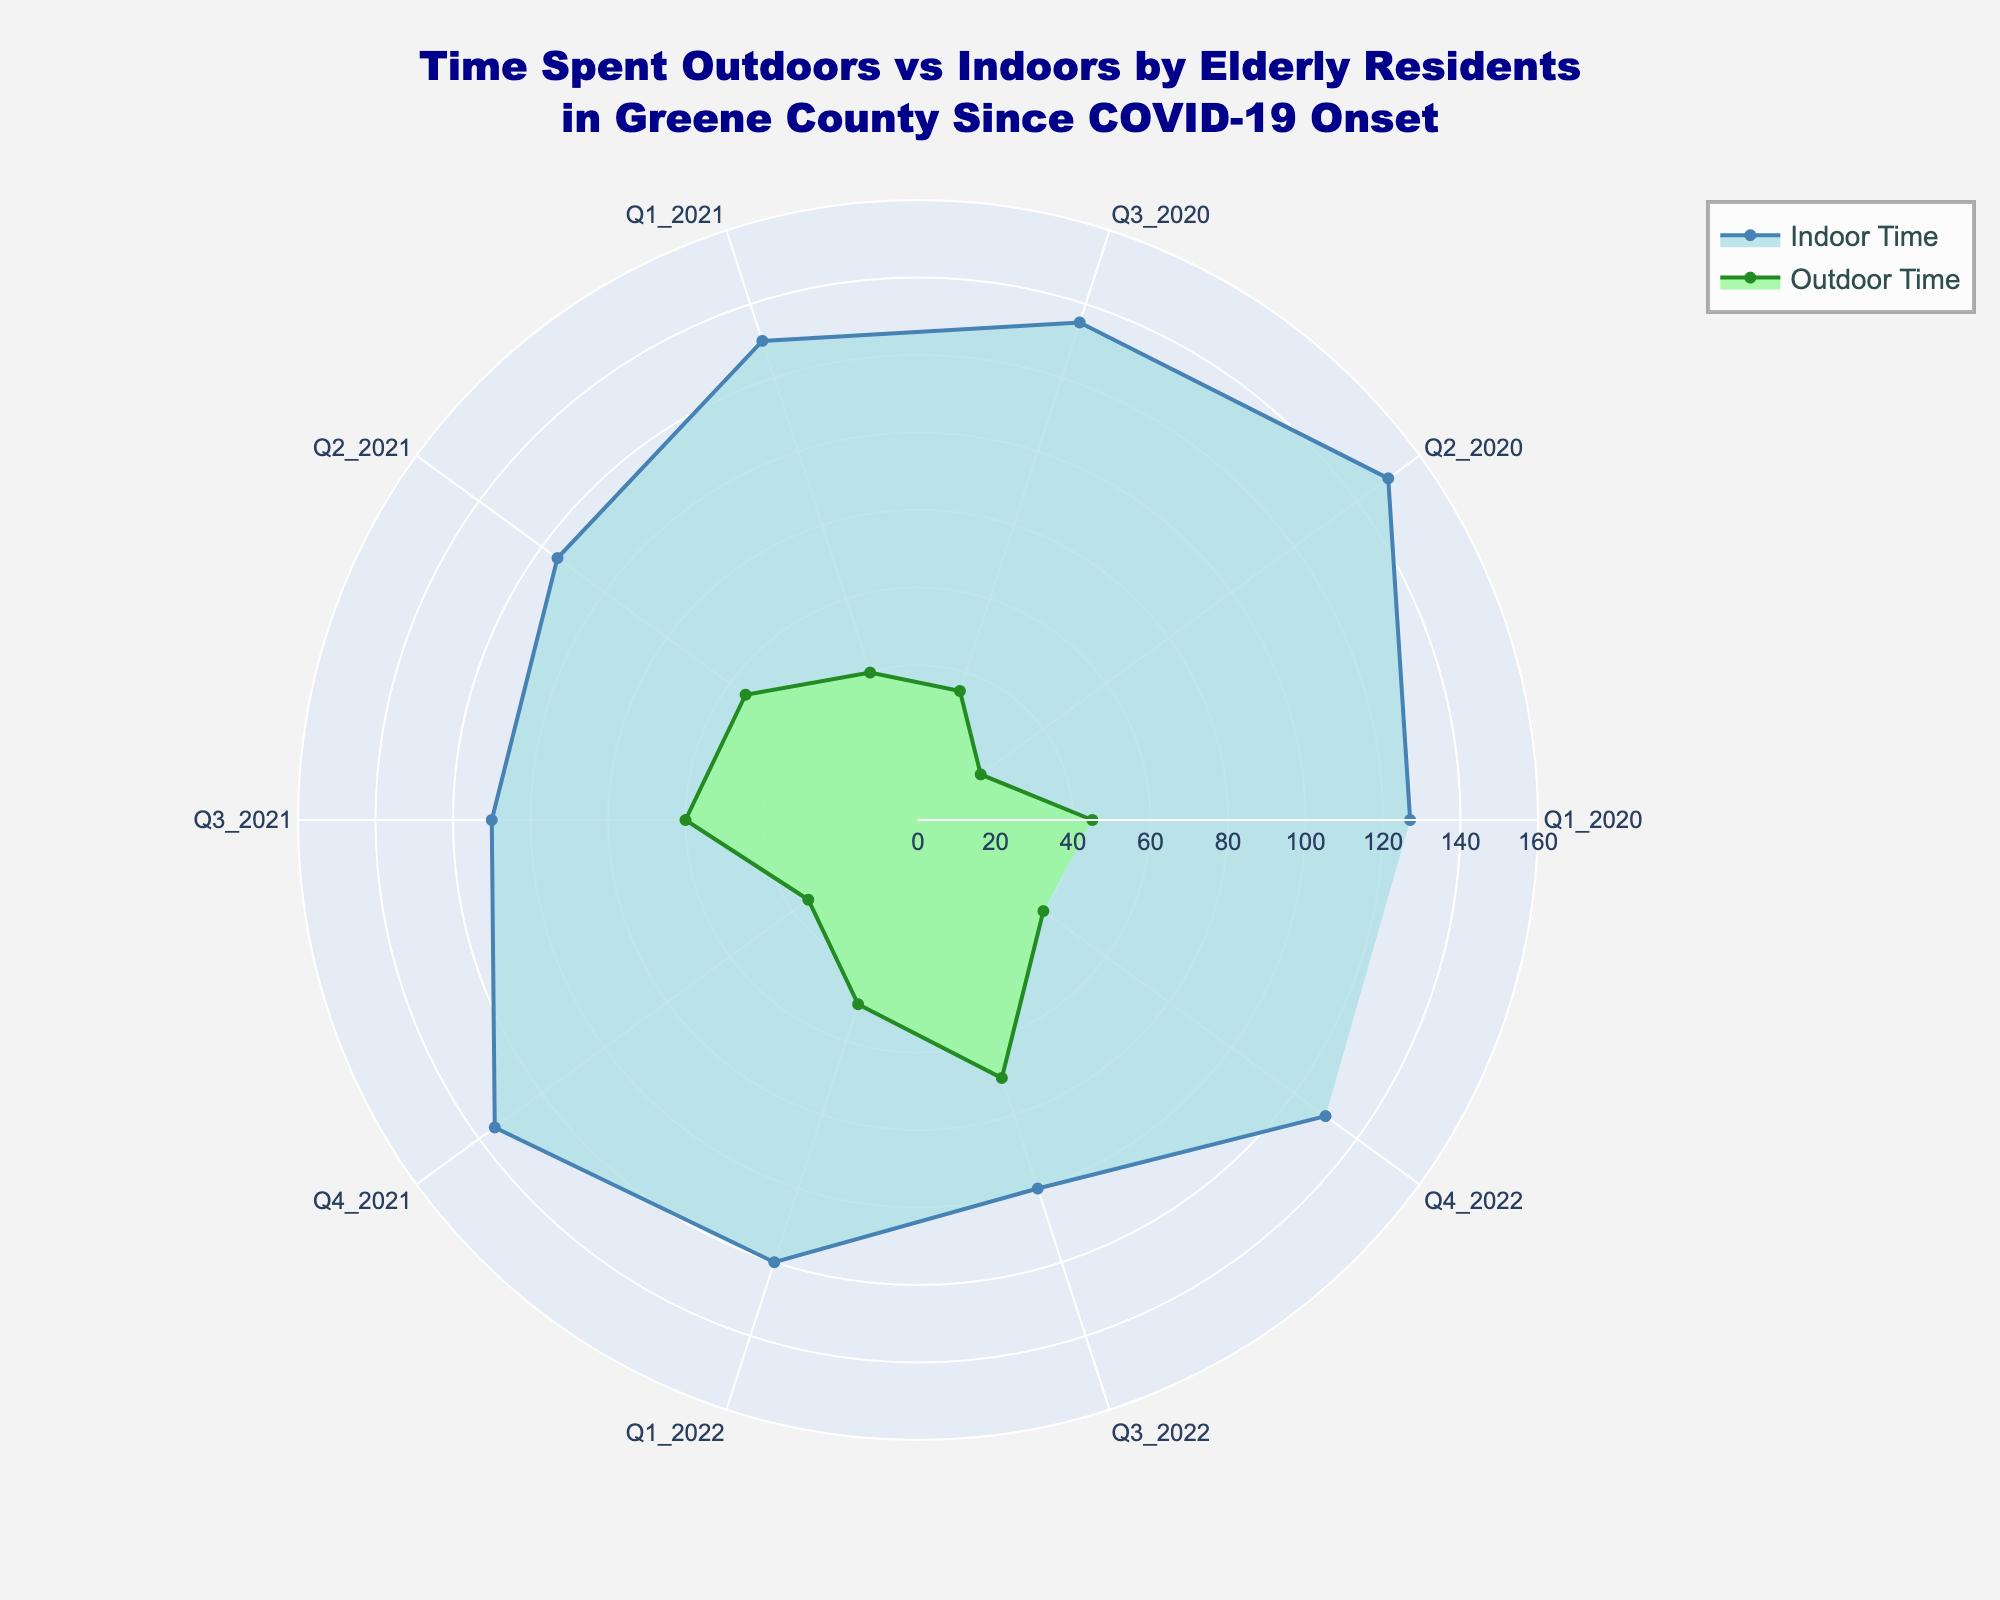What's the title of the figure? The title is written in a larger font at the top center of the figure. It summarizes the content of the chart.
Answer: Time Spent Outdoors vs Indoors by Elderly Residents in Greene County Since COVID-19 Onset How many time periods are depicted in the figure? The time periods are labeled around the radial axis, and each period corresponds to a sector in the rose chart.
Answer: 10 In which period was the time spent outdoors the lowest? To find the lowest value, look at the smallest radius for the "Outdoor Time" trace.
Answer: Q2_2020 What is the average time spent indoors from Q1_2020 to Q4_2020? Sum the indoor times for Q1_2020, Q2_2020, Q3_2020, and Q4_2020, then divide by the number of periods. (127 + 150 + 135 + 135) / 4 = 547 / 4 = 136.75
Answer: 136.75 Was there more time spent outdoors or indoors in Q3_2021? Compare the magnitudes of the indoor and outdoor traces for Q3_2021.
Answer: Outdoors Which time period has the largest difference between time spent indoors and outdoors? Calculate the differences for each period and find the maximum. For example, Q2_2020 has a difference of 150 - 20 = 130, Q3_2021 has a difference of 110 - 60 = 50, etc.
Answer: Q2_2020 How does the time spent outdoors in Q2_2021 compare to Q4_2022? Compare the radii for the "Outdoor Time" trace in Q2_2021 and Q4_2022.
Answer: Q2_2021 is greater What is the trend of time spent outdoors from Q1_2021 to Q3_2022? Observe the changes in the "Outdoor Time" trace for these periods. It appears to be increasing.
Answer: Increasing During which period do both the indoor and outdoor times show a decrease compared to the previous period? Evaluate changes for each successive period. For example, compare Q3_2021 to Q4_2021 and Q4_2021 to Q1_2022, etc.
Answer: Q4_2021 What is the change in indoor time from Q1_2022 to Q3_2022? Subtract the indoor time of Q3_2022 from Q1_2022. 120 - 100 = 20
Answer: -20 